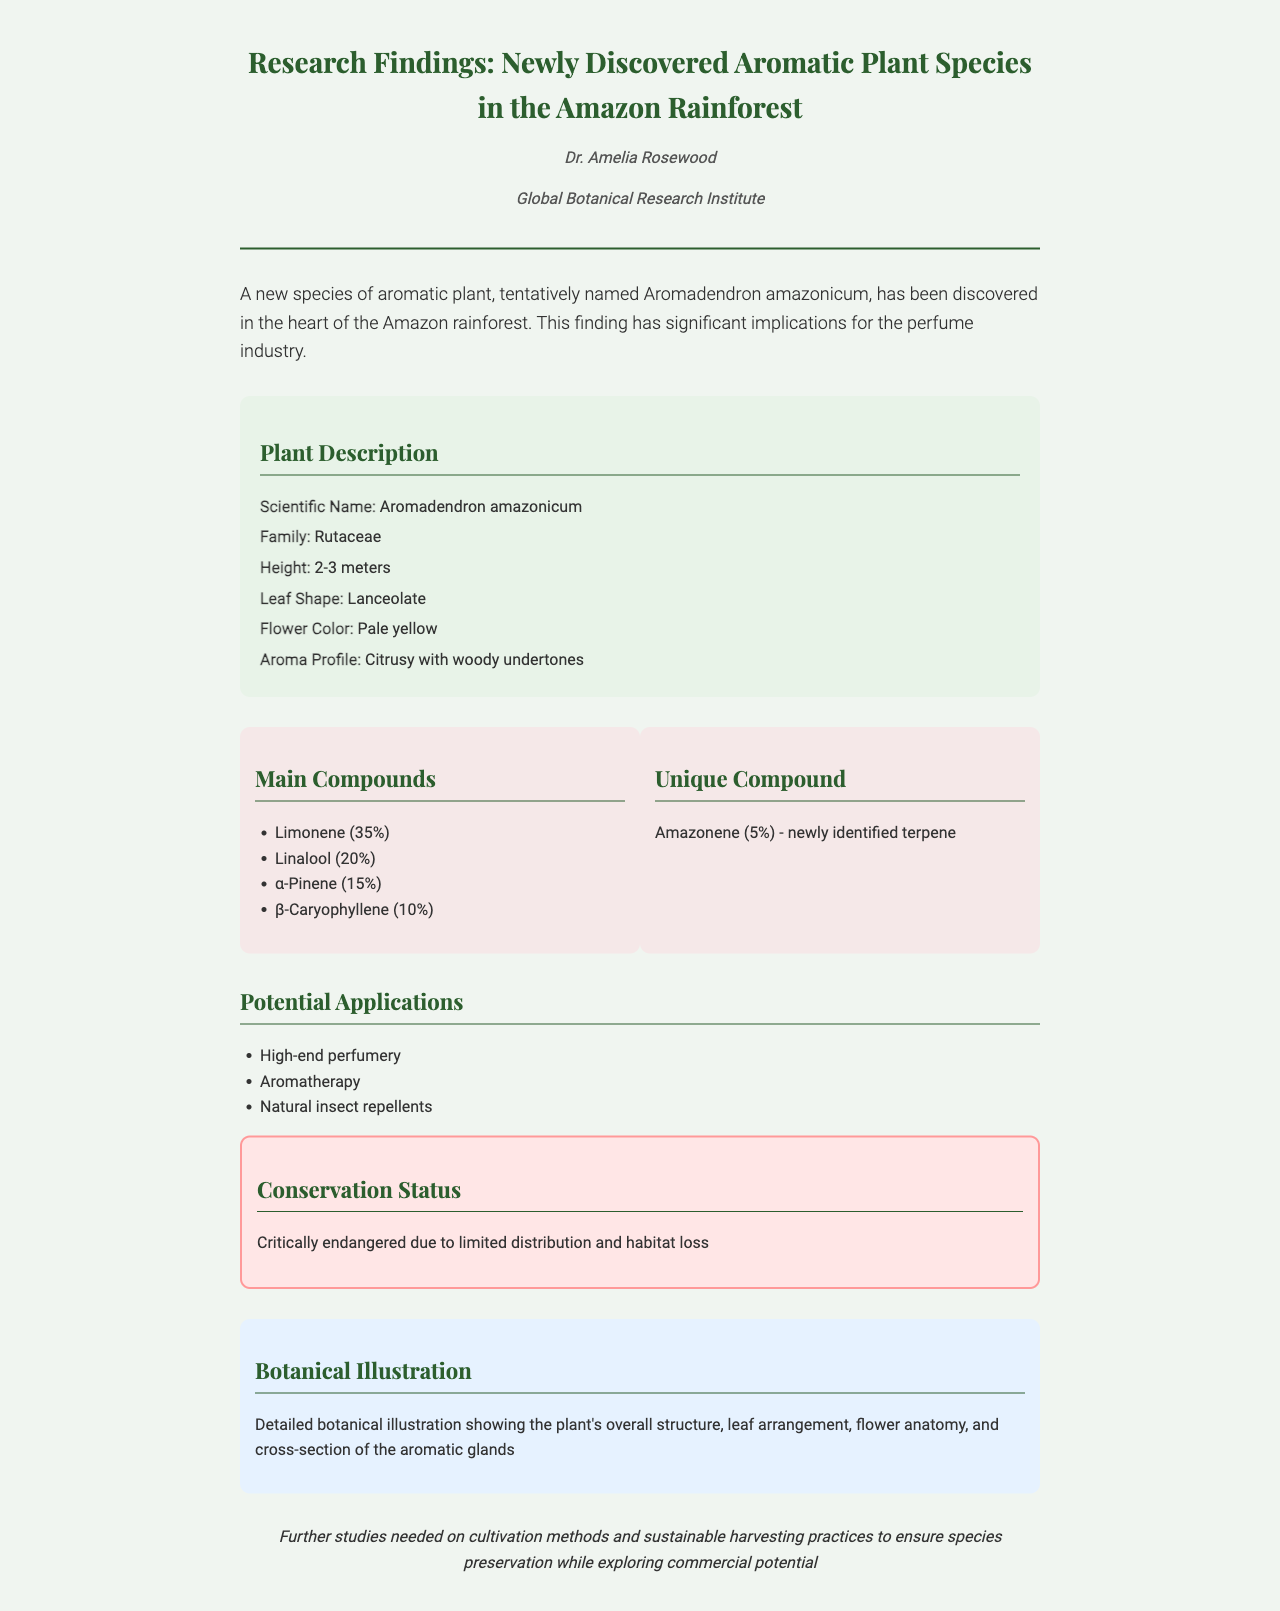What is the scientific name of the newly discovered plant? The scientific name is explicitly stated in the document as Aromadendron amazonicum.
Answer: Aromadendron amazonicum Which family does Aromadendron amazonicum belong to? The family is mentioned in the plant description section, indicating it is part of the Rutaceae family.
Answer: Rutaceae What is the height range of Aromadendron amazonicum? The document provides a specific height range of the plant, stating it typically reaches 2-3 meters tall.
Answer: 2-3 meters What is the unique compound found in this plant? The unique compound is specified in the chemical composition section as Amazonene, which is a newly identified terpene.
Answer: Amazonene What is the conservation status of Aromadendron amazonicum? The document clearly outlines its conservation status, noting it is critically endangered due to habitat loss.
Answer: Critically endangered What percentage of limonene is found in the main compounds? The percentage of limonene is stated in the chemical composition section as 35%.
Answer: 35% What are the potential applications mentioned for this plant? The document lists several potential applications, indicating its uses in high-end perfumery, aromatherapy, and as natural insect repellents.
Answer: High-end perfumery, Aromatherapy, Natural insect repellents What aspect of the plant does the botanical illustration depict? The document mentions that the botanical illustration shows the overall structure, leaf arrangement, flower anatomy, and cross-section of the aromatic glands.
Answer: Overall structure, leaf arrangement, flower anatomy, aromatic glands What is the next step suggested for research on this plant? The document highlights the need for further studies on cultivation methods and sustainable harvesting practices for the preservation of Aromadendron amazonicum.
Answer: Further studies on cultivation methods and sustainable harvesting practices 